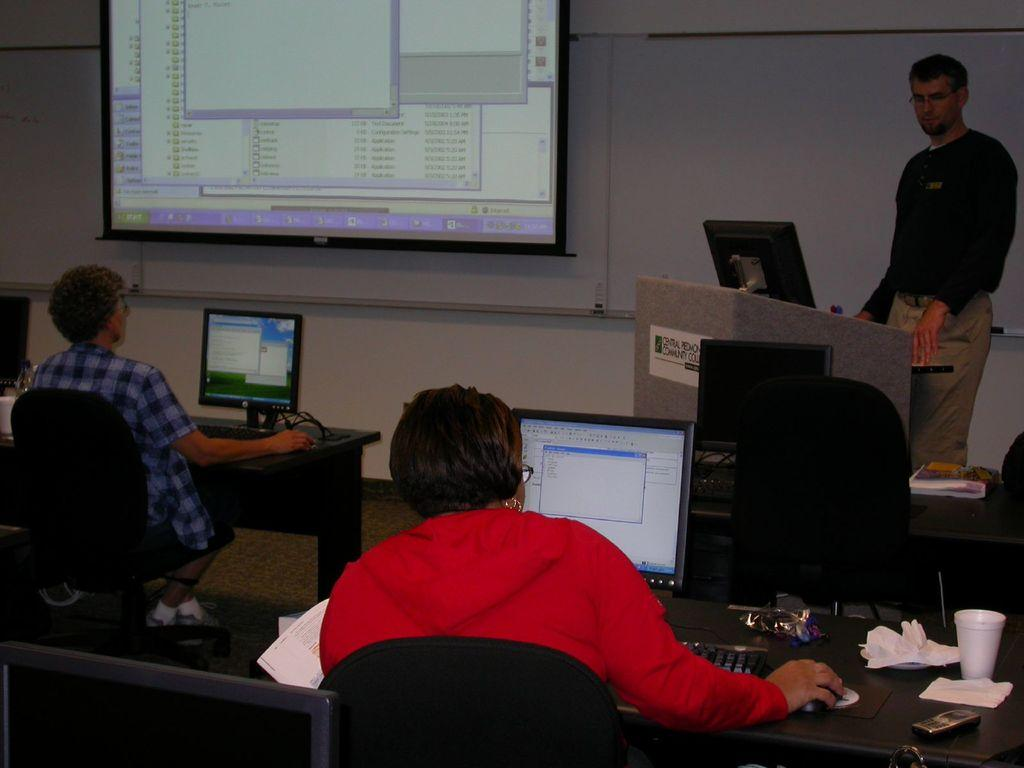Who is standing on the right side of the image? There is a man standing on the right side of the image. What object can be seen on a table in the image? There is a cup on a table in the image. What is located in the center of the image? There is a screen in the center of the image. What is the man on the right side of the image doing? A man is working on a system in the image. What is the woman in the image doing? The woman is sitting on a chair in the image. Where is the lettuce located in the image? There is no lettuce present in the image. What type of frog can be seen jumping on the screen in the image? There is no frog present in the image; it features a man working on a system and a woman sitting on a chair. 